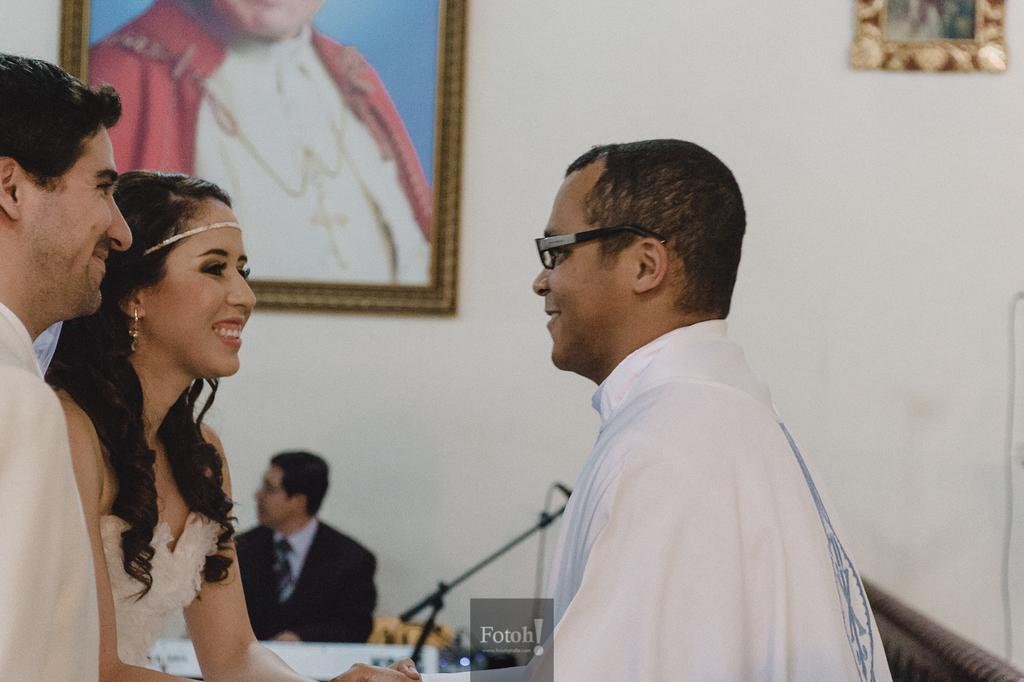What can be seen in the foreground of the image? There are people and text in the foreground of the image. What is located in the background of the image? There are frames, a person, a microphone, and other objects in the background of the image. Can you describe the carriage that is being pulled by the fowl in the image? There is no carriage or fowl present in the image. What type of bath can be seen in the background of the image? There is no bath present in the image. 